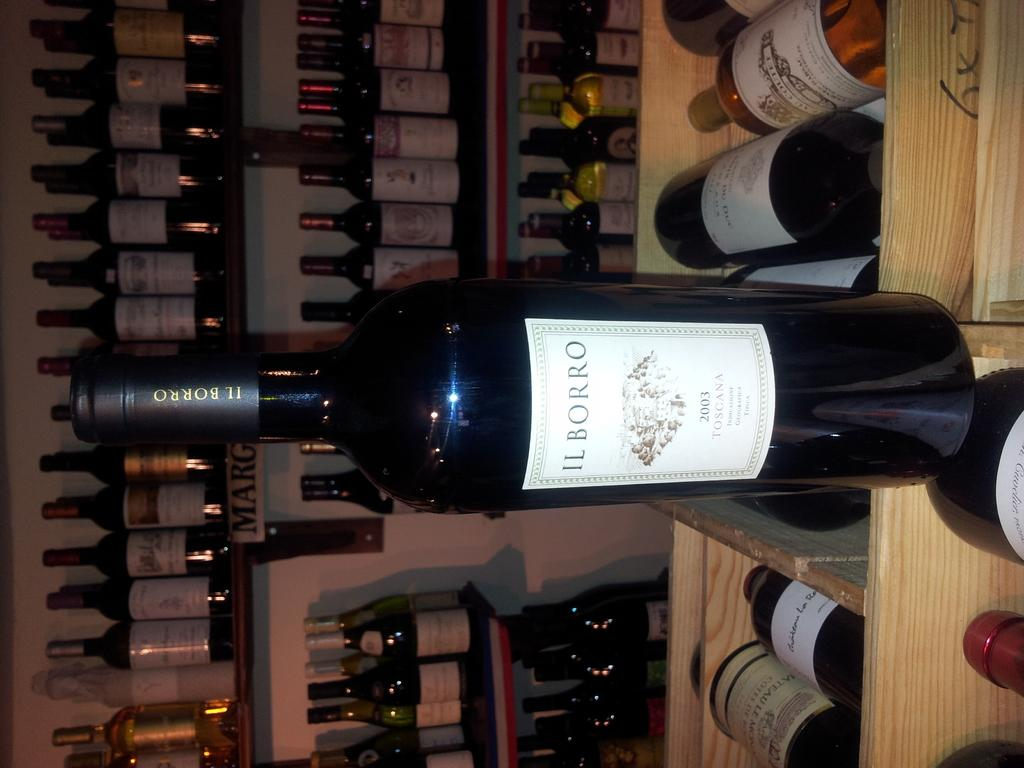<image>
Give a short and clear explanation of the subsequent image. A bottle of  a 2003 Il Borro red wine 